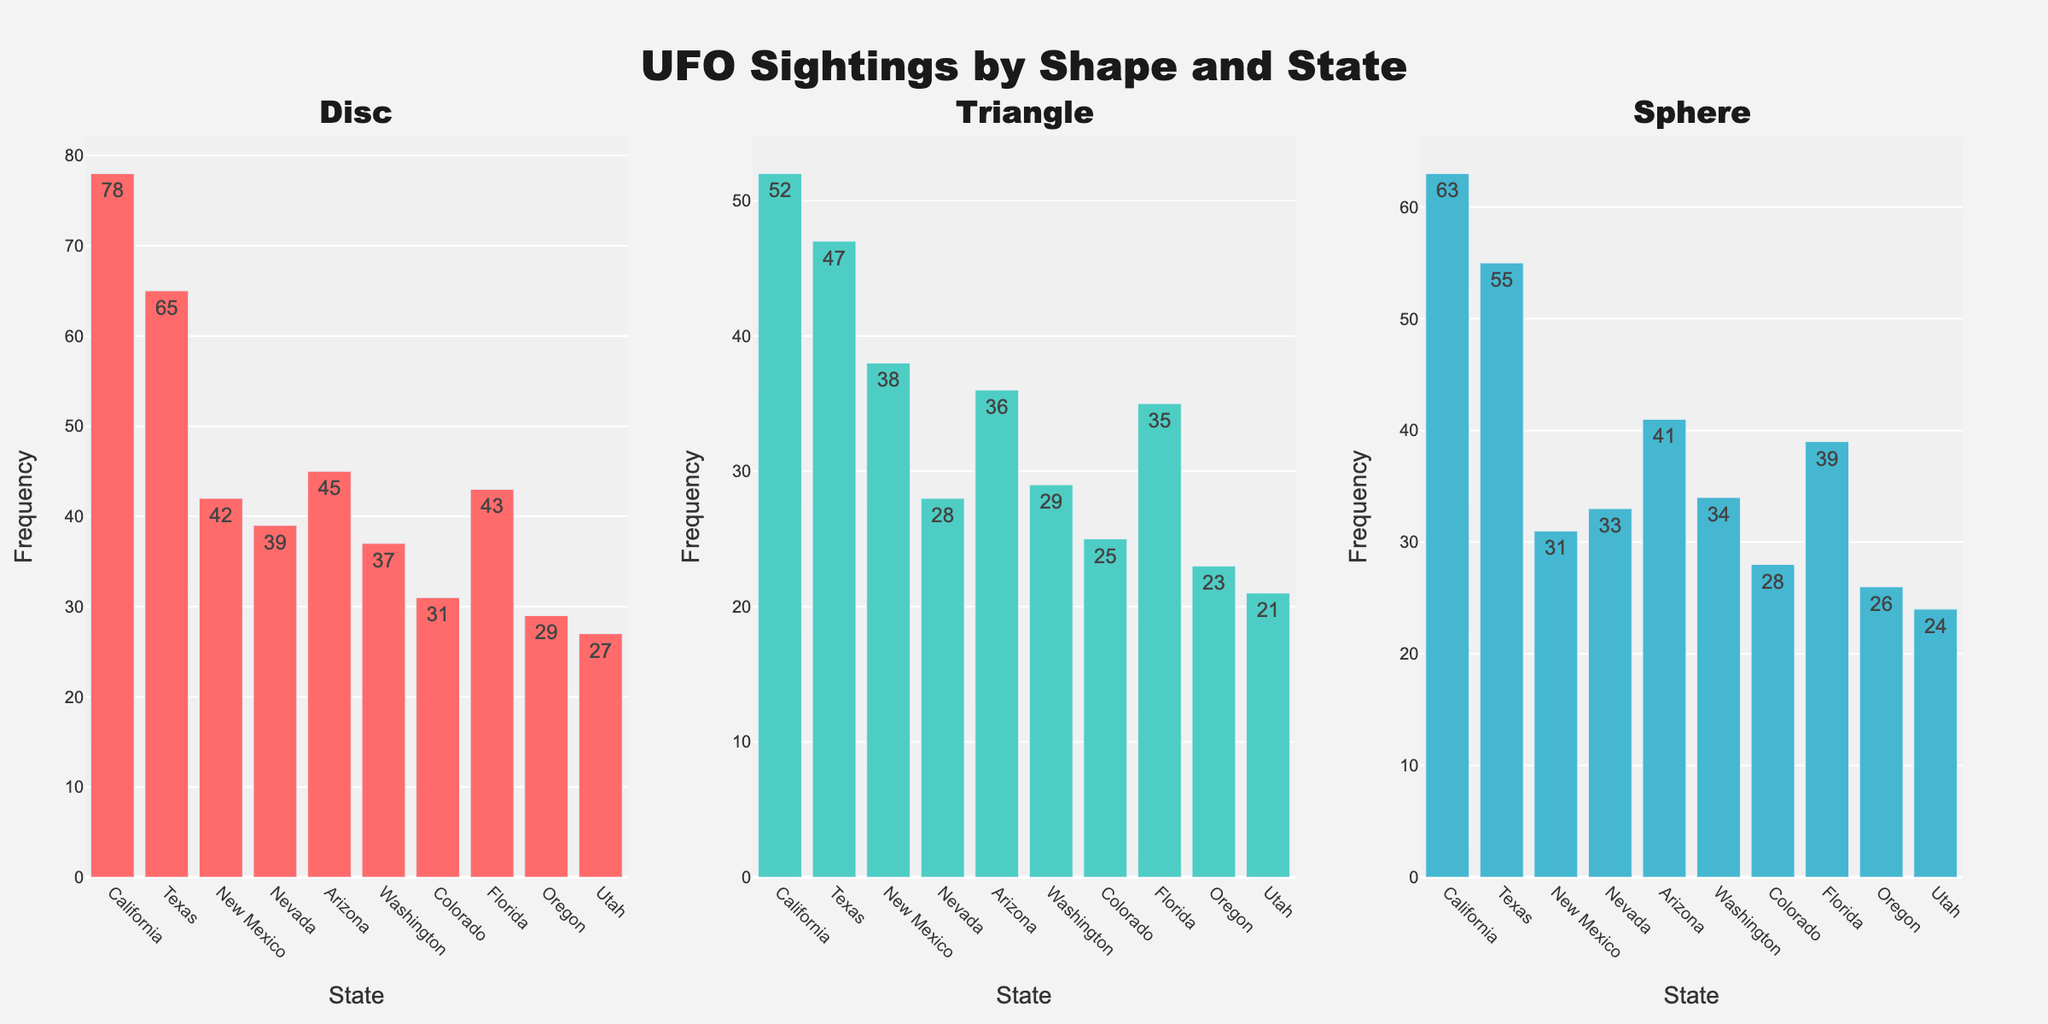Which state has the highest number of disc-shaped UFO sightings? The highest bar in the subplot for Disc-shaped UFO sightings belongs to California, which extends up to a frequency of 78. This indicates that California has the highest number of disc-shaped UFO sightings.
Answer: California Which shape has the lowest number of sightings in New Mexico? By comparing the bars for each shape in New Mexico, the Sphere has the lowest frequency, with a value of 31.
Answer: Sphere What is the total number of Sphere-shaped UFO sightings in California, Texas, and Florida combined? The frequencies for Sphere-shaped UFOs in California, Texas, and Florida are 63, 55, and 39 respectively. The total is 63 + 55 + 39 = 157.
Answer: 157 How many more disc-shaped sightings are there in California compared to Arizona? California has 78 disc-shaped sightings and Arizona has 45. The difference is 78 - 45 = 33.
Answer: 33 Which state has roughly equal numbers of triangle-shaped and sphere-shaped UFO sightings? By examining the subplots for Triangle and Sphere shapes, Arizona has similar frequencies for both: 36 Triangle and 41 Sphere.
Answer: Arizona What is the most frequently sighted shape in Texas? In the subplots, the highest frequency bar for Texas corresponds to the Disc shape, with a frequency of 65.
Answer: Disc Which state has the fewest total UFO sightings regardless of shape? Summing up the frequencies for all shapes in each state, Utah has the fewest total sightings: 27 (Disc) + 21 (Triangle) + 24 (Sphere) = 72.
Answer: Utah What's the difference in the number of disc-shaped UFO sightings between Florida and Washington? Florida has 43 disc-shaped sightings while Washington has 37. The difference is 43 - 37 = 6.
Answer: 6 Compare the total sightings of Triangle-shaped UFOs between New Mexico and Nevada. Which state has more? For Triangle-shaped sightings, New Mexico has 38 and Nevada has 28. New Mexico has 10 more sightings than Nevada.
Answer: New Mexico What's the average number of UFO sightings across all shapes in Colorado? The frequencies for Colorado are 31 (Disc), 25 (Triangle), and 28 (Sphere). The average is (31 + 25 + 28) / 3 = 28.
Answer: 28 